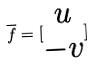Convert formula to latex. <formula><loc_0><loc_0><loc_500><loc_500>\overline { f } = [ \begin{matrix} u \\ - v \end{matrix} ]</formula> 